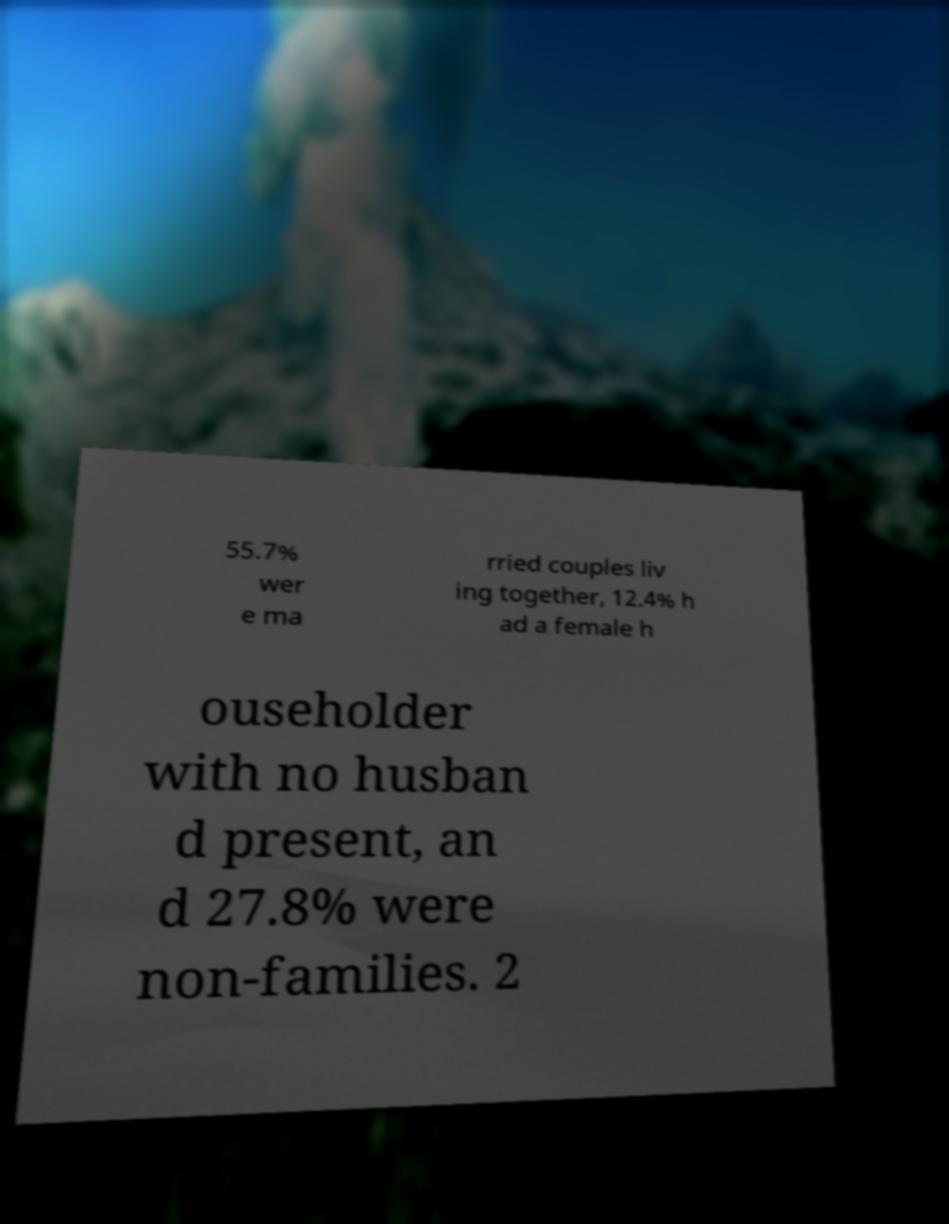Could you extract and type out the text from this image? 55.7% wer e ma rried couples liv ing together, 12.4% h ad a female h ouseholder with no husban d present, an d 27.8% were non-families. 2 